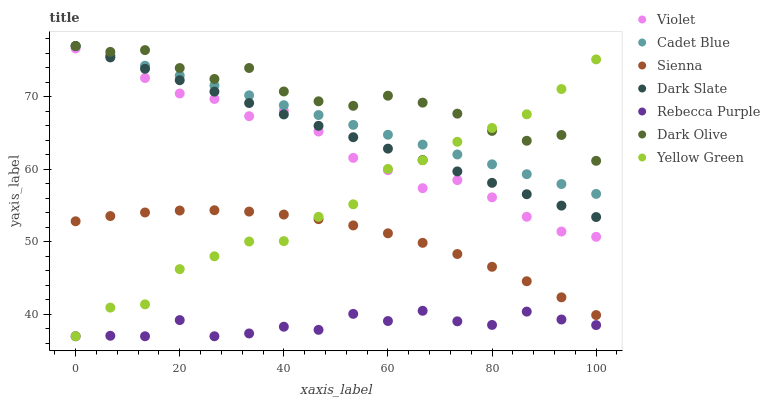Does Rebecca Purple have the minimum area under the curve?
Answer yes or no. Yes. Does Dark Olive have the maximum area under the curve?
Answer yes or no. Yes. Does Yellow Green have the minimum area under the curve?
Answer yes or no. No. Does Yellow Green have the maximum area under the curve?
Answer yes or no. No. Is Cadet Blue the smoothest?
Answer yes or no. Yes. Is Yellow Green the roughest?
Answer yes or no. Yes. Is Dark Olive the smoothest?
Answer yes or no. No. Is Dark Olive the roughest?
Answer yes or no. No. Does Yellow Green have the lowest value?
Answer yes or no. Yes. Does Dark Olive have the lowest value?
Answer yes or no. No. Does Dark Slate have the highest value?
Answer yes or no. Yes. Does Yellow Green have the highest value?
Answer yes or no. No. Is Sienna less than Dark Olive?
Answer yes or no. Yes. Is Dark Olive greater than Rebecca Purple?
Answer yes or no. Yes. Does Dark Olive intersect Cadet Blue?
Answer yes or no. Yes. Is Dark Olive less than Cadet Blue?
Answer yes or no. No. Is Dark Olive greater than Cadet Blue?
Answer yes or no. No. Does Sienna intersect Dark Olive?
Answer yes or no. No. 